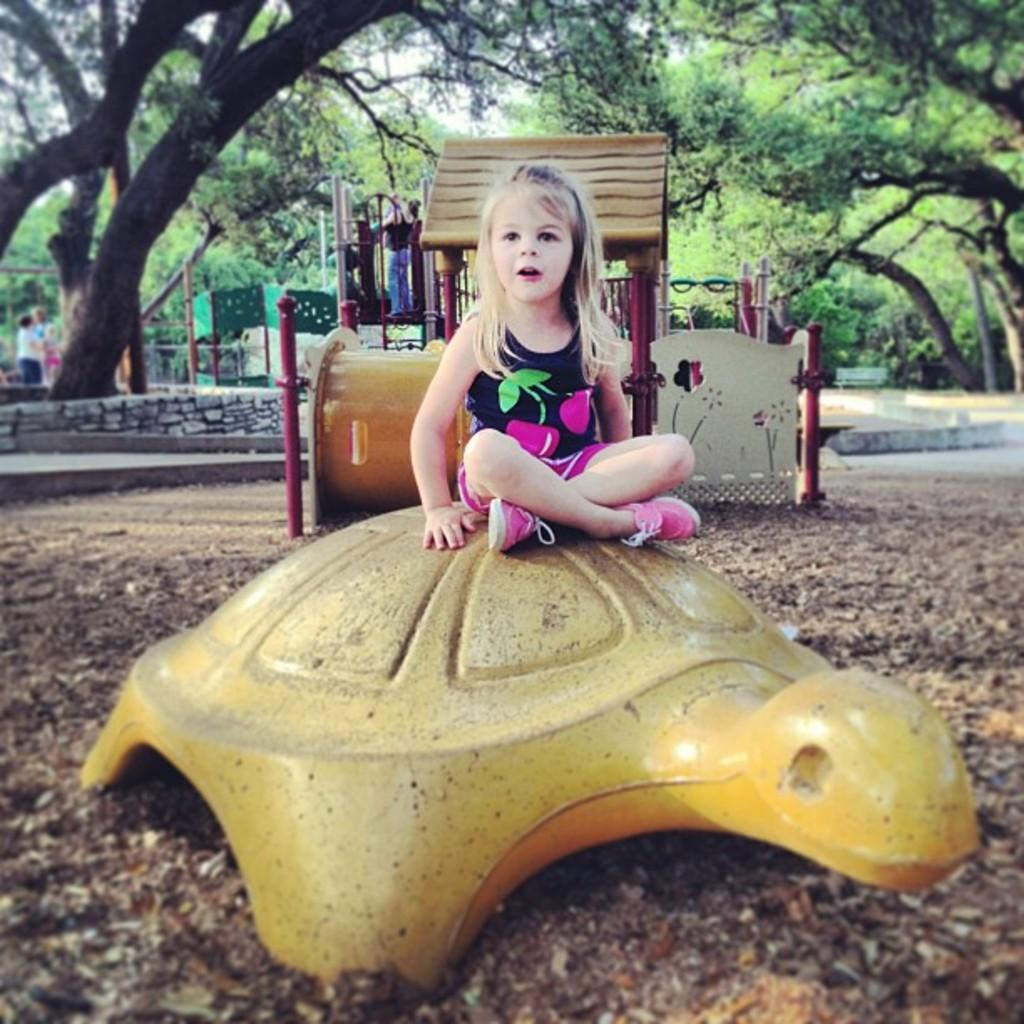Who is the main subject in the image? There is a girl in the image. What is the girl sitting on? The girl is sitting on a yellow, tortoise-shaped object. What can be seen in the background of the image? There are children, trees, a bench, and other objects in the background of the image. What type of trouble is the toad causing in the image? There is no toad present in the image, so it is not possible to determine if any trouble is being caused. 